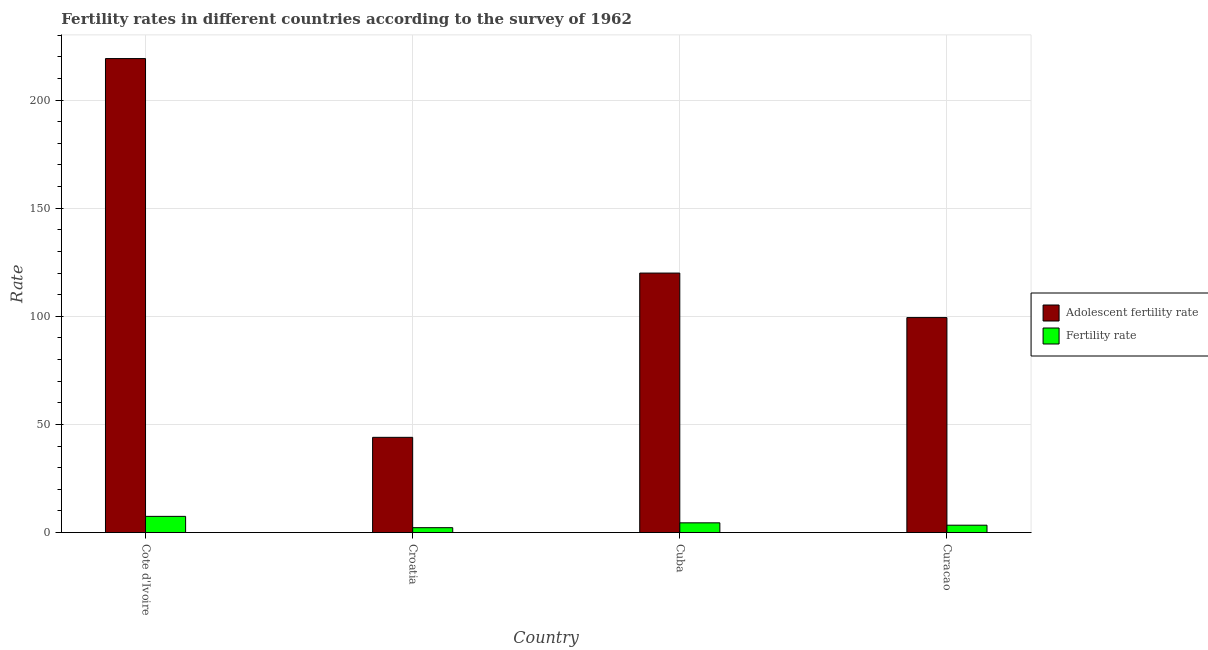How many groups of bars are there?
Provide a short and direct response. 4. Are the number of bars per tick equal to the number of legend labels?
Your answer should be compact. Yes. Are the number of bars on each tick of the X-axis equal?
Give a very brief answer. Yes. How many bars are there on the 3rd tick from the left?
Your response must be concise. 2. What is the label of the 3rd group of bars from the left?
Your answer should be very brief. Cuba. In how many cases, is the number of bars for a given country not equal to the number of legend labels?
Give a very brief answer. 0. What is the adolescent fertility rate in Cuba?
Your answer should be very brief. 120. Across all countries, what is the maximum fertility rate?
Provide a short and direct response. 7.5. Across all countries, what is the minimum fertility rate?
Ensure brevity in your answer.  2.27. In which country was the fertility rate maximum?
Provide a succinct answer. Cote d'Ivoire. In which country was the adolescent fertility rate minimum?
Provide a short and direct response. Croatia. What is the total fertility rate in the graph?
Your answer should be very brief. 17.7. What is the difference between the fertility rate in Croatia and that in Cuba?
Offer a terse response. -2.24. What is the difference between the fertility rate in Cuba and the adolescent fertility rate in Cote d'Ivoire?
Ensure brevity in your answer.  -214.67. What is the average adolescent fertility rate per country?
Give a very brief answer. 120.66. What is the difference between the adolescent fertility rate and fertility rate in Curacao?
Keep it short and to the point. 96. In how many countries, is the fertility rate greater than 150 ?
Your response must be concise. 0. What is the ratio of the adolescent fertility rate in Cote d'Ivoire to that in Curacao?
Your answer should be compact. 2.2. Is the difference between the fertility rate in Croatia and Cuba greater than the difference between the adolescent fertility rate in Croatia and Cuba?
Ensure brevity in your answer.  Yes. What is the difference between the highest and the second highest fertility rate?
Your answer should be compact. 2.99. What is the difference between the highest and the lowest fertility rate?
Ensure brevity in your answer.  5.23. Is the sum of the fertility rate in Cote d'Ivoire and Croatia greater than the maximum adolescent fertility rate across all countries?
Offer a very short reply. No. What does the 1st bar from the left in Curacao represents?
Provide a short and direct response. Adolescent fertility rate. What does the 1st bar from the right in Curacao represents?
Offer a very short reply. Fertility rate. How many bars are there?
Provide a short and direct response. 8. Are all the bars in the graph horizontal?
Provide a succinct answer. No. How many countries are there in the graph?
Make the answer very short. 4. What is the difference between two consecutive major ticks on the Y-axis?
Give a very brief answer. 50. Does the graph contain any zero values?
Provide a succinct answer. No. Does the graph contain grids?
Provide a succinct answer. Yes. What is the title of the graph?
Make the answer very short. Fertility rates in different countries according to the survey of 1962. Does "Travel Items" appear as one of the legend labels in the graph?
Your answer should be very brief. No. What is the label or title of the Y-axis?
Provide a succinct answer. Rate. What is the Rate in Adolescent fertility rate in Cote d'Ivoire?
Ensure brevity in your answer.  219.18. What is the Rate in Fertility rate in Cote d'Ivoire?
Make the answer very short. 7.5. What is the Rate in Adolescent fertility rate in Croatia?
Make the answer very short. 44.05. What is the Rate of Fertility rate in Croatia?
Keep it short and to the point. 2.27. What is the Rate in Adolescent fertility rate in Cuba?
Ensure brevity in your answer.  120. What is the Rate in Fertility rate in Cuba?
Offer a terse response. 4.51. What is the Rate in Adolescent fertility rate in Curacao?
Ensure brevity in your answer.  99.42. What is the Rate in Fertility rate in Curacao?
Provide a short and direct response. 3.42. Across all countries, what is the maximum Rate in Adolescent fertility rate?
Ensure brevity in your answer.  219.18. Across all countries, what is the maximum Rate of Fertility rate?
Keep it short and to the point. 7.5. Across all countries, what is the minimum Rate of Adolescent fertility rate?
Ensure brevity in your answer.  44.05. Across all countries, what is the minimum Rate of Fertility rate?
Provide a short and direct response. 2.27. What is the total Rate of Adolescent fertility rate in the graph?
Provide a short and direct response. 482.64. What is the total Rate of Fertility rate in the graph?
Your answer should be compact. 17.7. What is the difference between the Rate in Adolescent fertility rate in Cote d'Ivoire and that in Croatia?
Offer a terse response. 175.14. What is the difference between the Rate of Fertility rate in Cote d'Ivoire and that in Croatia?
Provide a succinct answer. 5.23. What is the difference between the Rate in Adolescent fertility rate in Cote d'Ivoire and that in Cuba?
Your response must be concise. 99.18. What is the difference between the Rate of Fertility rate in Cote d'Ivoire and that in Cuba?
Provide a succinct answer. 2.99. What is the difference between the Rate in Adolescent fertility rate in Cote d'Ivoire and that in Curacao?
Provide a succinct answer. 119.76. What is the difference between the Rate in Fertility rate in Cote d'Ivoire and that in Curacao?
Provide a succinct answer. 4.08. What is the difference between the Rate of Adolescent fertility rate in Croatia and that in Cuba?
Keep it short and to the point. -75.95. What is the difference between the Rate in Fertility rate in Croatia and that in Cuba?
Your answer should be very brief. -2.24. What is the difference between the Rate in Adolescent fertility rate in Croatia and that in Curacao?
Your response must be concise. -55.37. What is the difference between the Rate in Fertility rate in Croatia and that in Curacao?
Your answer should be compact. -1.15. What is the difference between the Rate of Adolescent fertility rate in Cuba and that in Curacao?
Keep it short and to the point. 20.58. What is the difference between the Rate in Fertility rate in Cuba and that in Curacao?
Your answer should be compact. 1.09. What is the difference between the Rate in Adolescent fertility rate in Cote d'Ivoire and the Rate in Fertility rate in Croatia?
Ensure brevity in your answer.  216.91. What is the difference between the Rate in Adolescent fertility rate in Cote d'Ivoire and the Rate in Fertility rate in Cuba?
Ensure brevity in your answer.  214.67. What is the difference between the Rate in Adolescent fertility rate in Cote d'Ivoire and the Rate in Fertility rate in Curacao?
Ensure brevity in your answer.  215.76. What is the difference between the Rate in Adolescent fertility rate in Croatia and the Rate in Fertility rate in Cuba?
Offer a terse response. 39.54. What is the difference between the Rate of Adolescent fertility rate in Croatia and the Rate of Fertility rate in Curacao?
Keep it short and to the point. 40.62. What is the difference between the Rate of Adolescent fertility rate in Cuba and the Rate of Fertility rate in Curacao?
Your answer should be very brief. 116.58. What is the average Rate of Adolescent fertility rate per country?
Your response must be concise. 120.66. What is the average Rate of Fertility rate per country?
Your response must be concise. 4.43. What is the difference between the Rate in Adolescent fertility rate and Rate in Fertility rate in Cote d'Ivoire?
Your answer should be compact. 211.68. What is the difference between the Rate in Adolescent fertility rate and Rate in Fertility rate in Croatia?
Your answer should be very brief. 41.77. What is the difference between the Rate of Adolescent fertility rate and Rate of Fertility rate in Cuba?
Your response must be concise. 115.49. What is the difference between the Rate in Adolescent fertility rate and Rate in Fertility rate in Curacao?
Provide a succinct answer. 96. What is the ratio of the Rate in Adolescent fertility rate in Cote d'Ivoire to that in Croatia?
Offer a terse response. 4.98. What is the ratio of the Rate in Fertility rate in Cote d'Ivoire to that in Croatia?
Provide a short and direct response. 3.3. What is the ratio of the Rate in Adolescent fertility rate in Cote d'Ivoire to that in Cuba?
Your response must be concise. 1.83. What is the ratio of the Rate of Fertility rate in Cote d'Ivoire to that in Cuba?
Provide a short and direct response. 1.66. What is the ratio of the Rate in Adolescent fertility rate in Cote d'Ivoire to that in Curacao?
Ensure brevity in your answer.  2.2. What is the ratio of the Rate in Fertility rate in Cote d'Ivoire to that in Curacao?
Give a very brief answer. 2.19. What is the ratio of the Rate of Adolescent fertility rate in Croatia to that in Cuba?
Your response must be concise. 0.37. What is the ratio of the Rate of Fertility rate in Croatia to that in Cuba?
Your answer should be compact. 0.5. What is the ratio of the Rate in Adolescent fertility rate in Croatia to that in Curacao?
Make the answer very short. 0.44. What is the ratio of the Rate in Fertility rate in Croatia to that in Curacao?
Make the answer very short. 0.66. What is the ratio of the Rate in Adolescent fertility rate in Cuba to that in Curacao?
Make the answer very short. 1.21. What is the ratio of the Rate in Fertility rate in Cuba to that in Curacao?
Offer a very short reply. 1.32. What is the difference between the highest and the second highest Rate of Adolescent fertility rate?
Make the answer very short. 99.18. What is the difference between the highest and the second highest Rate in Fertility rate?
Provide a short and direct response. 2.99. What is the difference between the highest and the lowest Rate in Adolescent fertility rate?
Your answer should be very brief. 175.14. What is the difference between the highest and the lowest Rate of Fertility rate?
Offer a terse response. 5.23. 